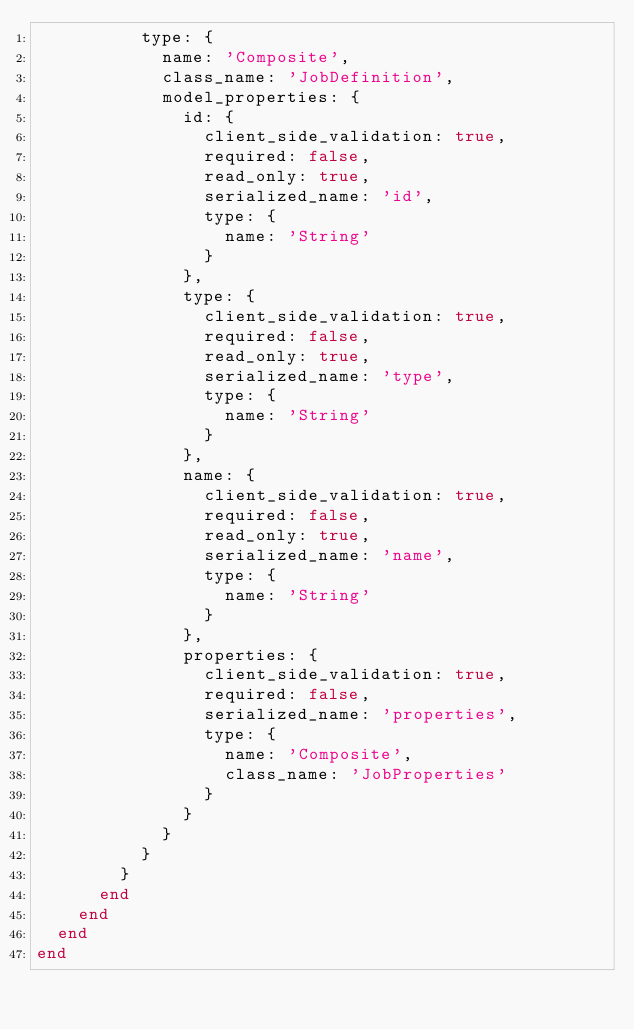<code> <loc_0><loc_0><loc_500><loc_500><_Ruby_>          type: {
            name: 'Composite',
            class_name: 'JobDefinition',
            model_properties: {
              id: {
                client_side_validation: true,
                required: false,
                read_only: true,
                serialized_name: 'id',
                type: {
                  name: 'String'
                }
              },
              type: {
                client_side_validation: true,
                required: false,
                read_only: true,
                serialized_name: 'type',
                type: {
                  name: 'String'
                }
              },
              name: {
                client_side_validation: true,
                required: false,
                read_only: true,
                serialized_name: 'name',
                type: {
                  name: 'String'
                }
              },
              properties: {
                client_side_validation: true,
                required: false,
                serialized_name: 'properties',
                type: {
                  name: 'Composite',
                  class_name: 'JobProperties'
                }
              }
            }
          }
        }
      end
    end
  end
end
</code> 